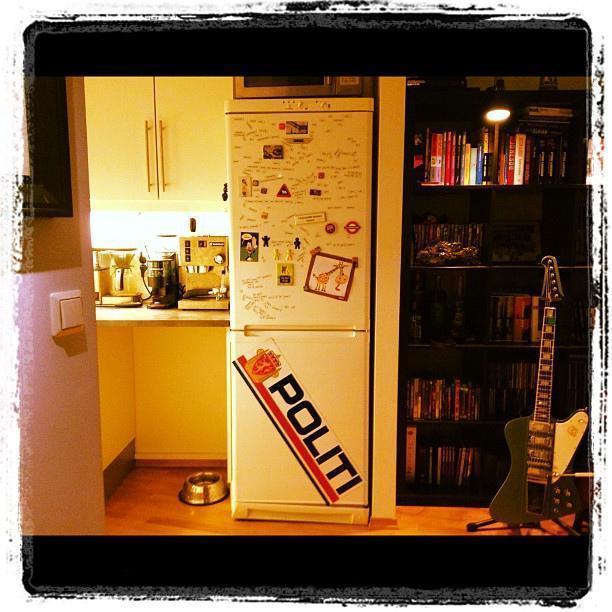In what nation is this apartment likely to be situated?
From the following four choices, select the correct answer to address the question.
Options: England, denmark, france, canada. Denmark. 